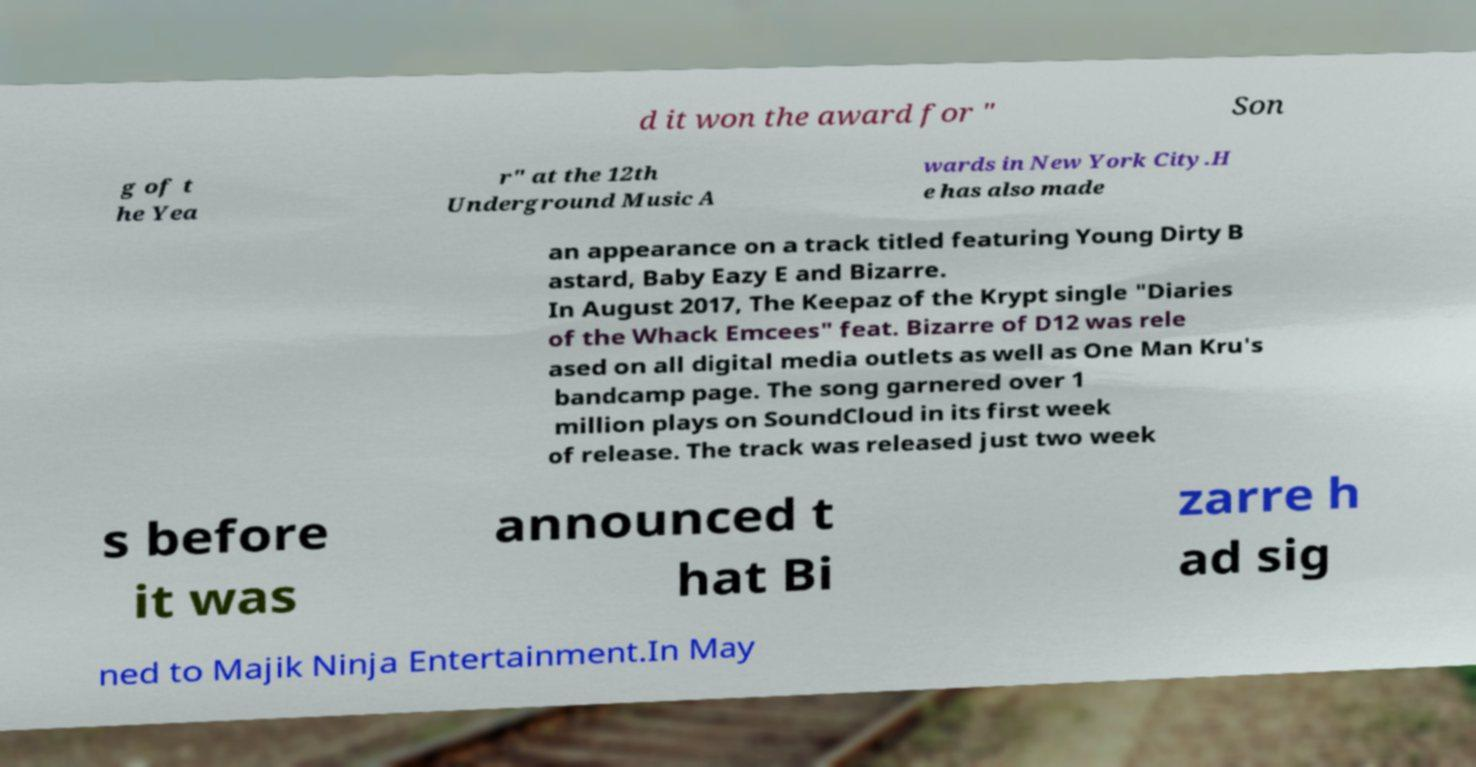Please read and relay the text visible in this image. What does it say? d it won the award for " Son g of t he Yea r" at the 12th Underground Music A wards in New York City.H e has also made an appearance on a track titled featuring Young Dirty B astard, Baby Eazy E and Bizarre. In August 2017, The Keepaz of the Krypt single "Diaries of the Whack Emcees" feat. Bizarre of D12 was rele ased on all digital media outlets as well as One Man Kru's bandcamp page. The song garnered over 1 million plays on SoundCloud in its first week of release. The track was released just two week s before it was announced t hat Bi zarre h ad sig ned to Majik Ninja Entertainment.In May 